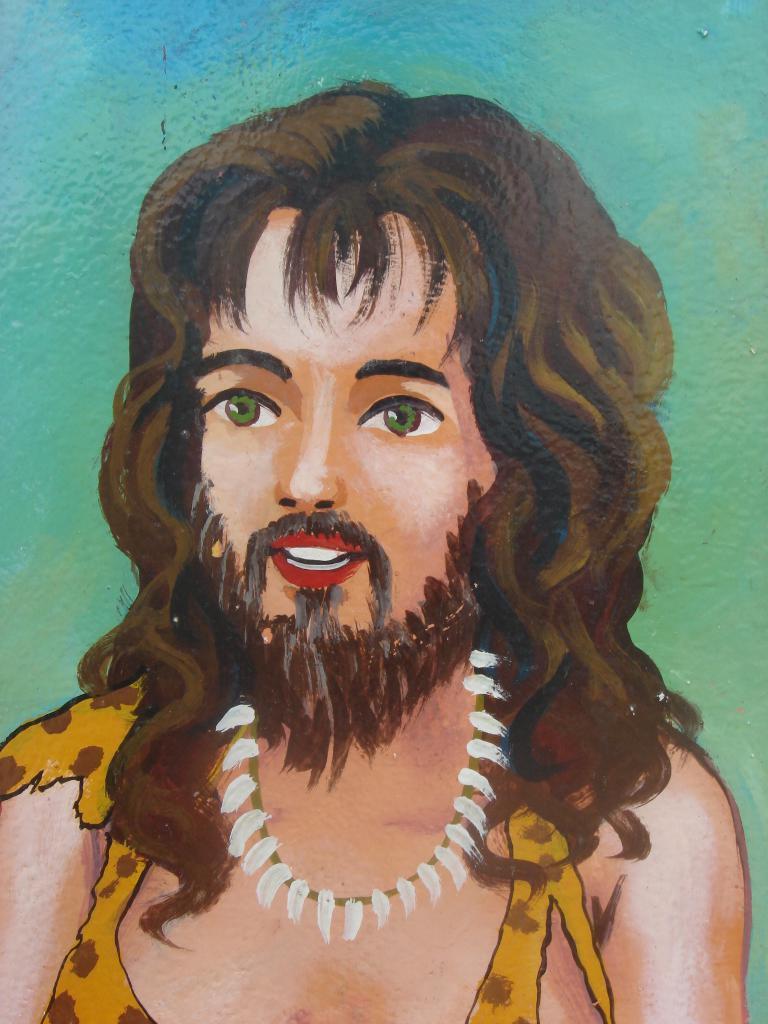How would you summarize this image in a sentence or two? In this image I can see a person's painting and a multicolored background. This image looks like a painting. 